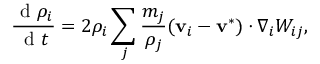Convert formula to latex. <formula><loc_0><loc_0><loc_500><loc_500>\frac { d \rho _ { i } } { d t } = 2 \rho _ { i } \sum _ { j } \frac { m _ { j } } { \rho _ { j } } ( v _ { i } - v ^ { * } ) \cdot \nabla _ { i } W _ { i j } ,</formula> 